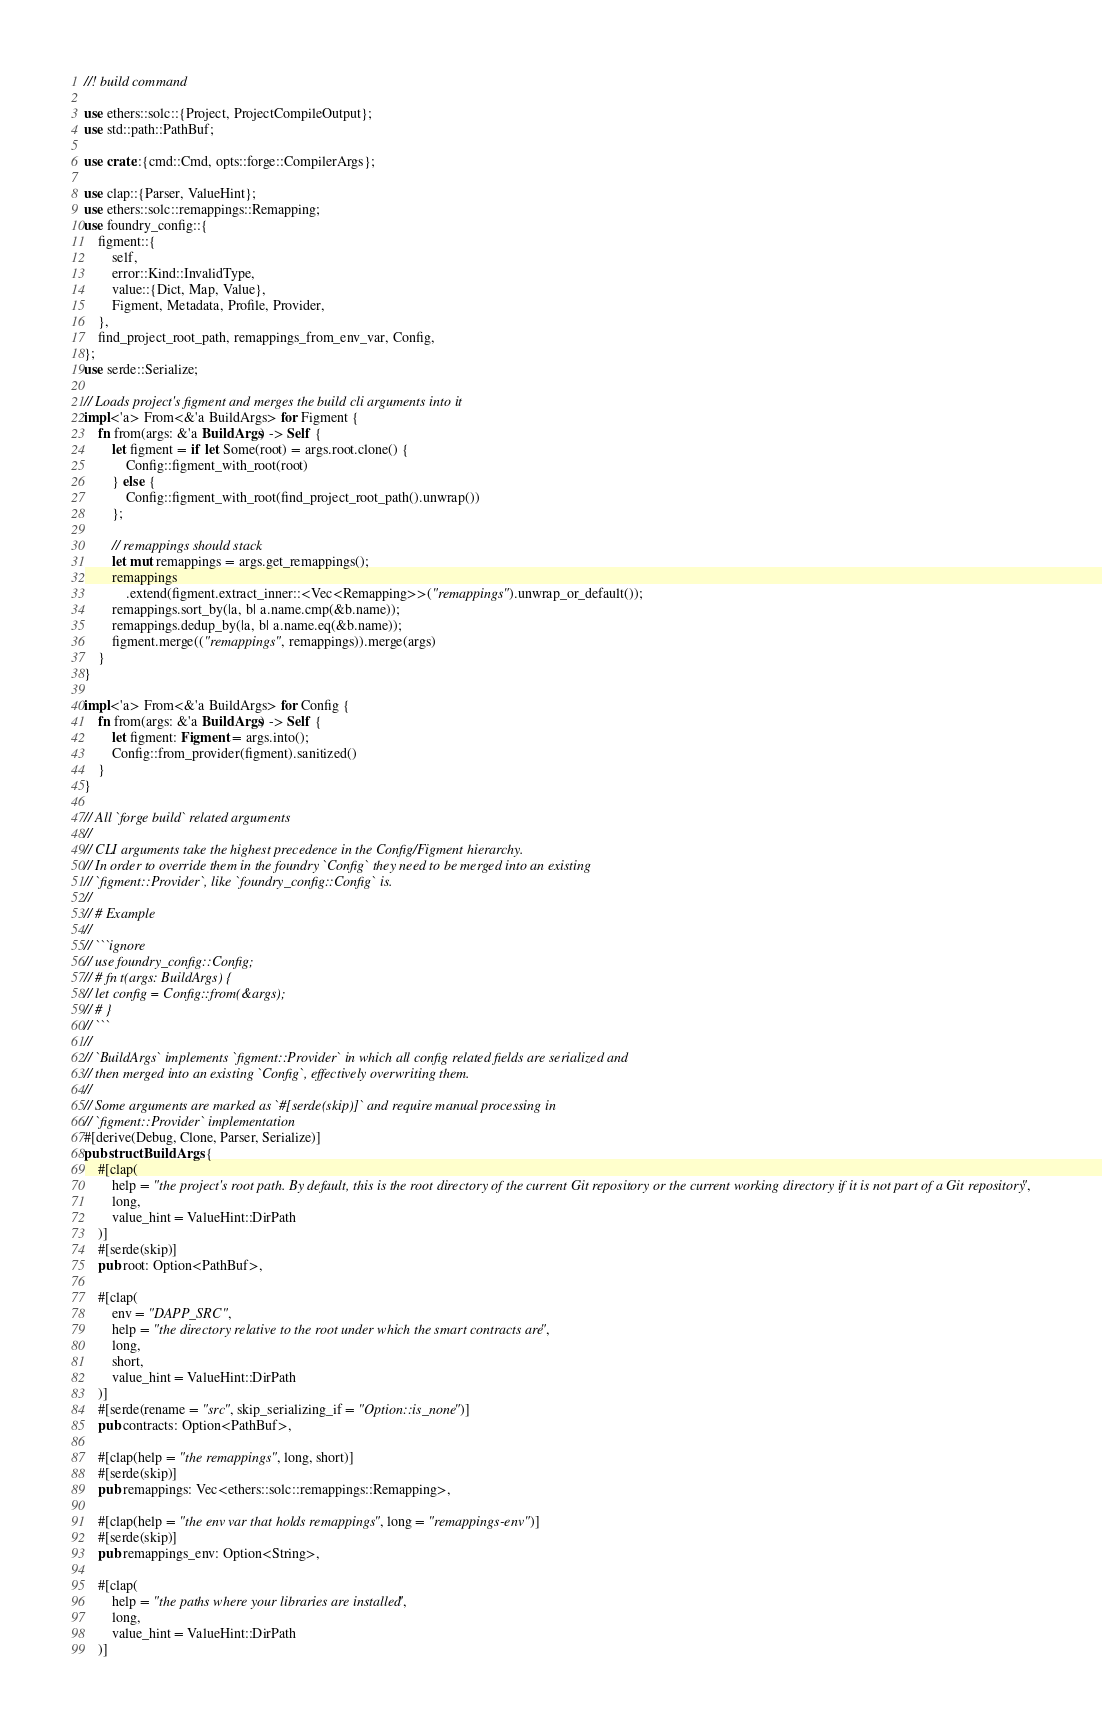<code> <loc_0><loc_0><loc_500><loc_500><_Rust_>//! build command

use ethers::solc::{Project, ProjectCompileOutput};
use std::path::PathBuf;

use crate::{cmd::Cmd, opts::forge::CompilerArgs};

use clap::{Parser, ValueHint};
use ethers::solc::remappings::Remapping;
use foundry_config::{
    figment::{
        self,
        error::Kind::InvalidType,
        value::{Dict, Map, Value},
        Figment, Metadata, Profile, Provider,
    },
    find_project_root_path, remappings_from_env_var, Config,
};
use serde::Serialize;

// Loads project's figment and merges the build cli arguments into it
impl<'a> From<&'a BuildArgs> for Figment {
    fn from(args: &'a BuildArgs) -> Self {
        let figment = if let Some(root) = args.root.clone() {
            Config::figment_with_root(root)
        } else {
            Config::figment_with_root(find_project_root_path().unwrap())
        };

        // remappings should stack
        let mut remappings = args.get_remappings();
        remappings
            .extend(figment.extract_inner::<Vec<Remapping>>("remappings").unwrap_or_default());
        remappings.sort_by(|a, b| a.name.cmp(&b.name));
        remappings.dedup_by(|a, b| a.name.eq(&b.name));
        figment.merge(("remappings", remappings)).merge(args)
    }
}

impl<'a> From<&'a BuildArgs> for Config {
    fn from(args: &'a BuildArgs) -> Self {
        let figment: Figment = args.into();
        Config::from_provider(figment).sanitized()
    }
}

// All `forge build` related arguments
//
// CLI arguments take the highest precedence in the Config/Figment hierarchy.
// In order to override them in the foundry `Config` they need to be merged into an existing
// `figment::Provider`, like `foundry_config::Config` is.
//
// # Example
//
// ```ignore
// use foundry_config::Config;
// # fn t(args: BuildArgs) {
// let config = Config::from(&args);
// # }
// ```
//
// `BuildArgs` implements `figment::Provider` in which all config related fields are serialized and
// then merged into an existing `Config`, effectively overwriting them.
//
// Some arguments are marked as `#[serde(skip)]` and require manual processing in
// `figment::Provider` implementation
#[derive(Debug, Clone, Parser, Serialize)]
pub struct BuildArgs {
    #[clap(
        help = "the project's root path. By default, this is the root directory of the current Git repository or the current working directory if it is not part of a Git repository",
        long,
        value_hint = ValueHint::DirPath
    )]
    #[serde(skip)]
    pub root: Option<PathBuf>,

    #[clap(
        env = "DAPP_SRC",
        help = "the directory relative to the root under which the smart contracts are",
        long,
        short,
        value_hint = ValueHint::DirPath
    )]
    #[serde(rename = "src", skip_serializing_if = "Option::is_none")]
    pub contracts: Option<PathBuf>,

    #[clap(help = "the remappings", long, short)]
    #[serde(skip)]
    pub remappings: Vec<ethers::solc::remappings::Remapping>,

    #[clap(help = "the env var that holds remappings", long = "remappings-env")]
    #[serde(skip)]
    pub remappings_env: Option<String>,

    #[clap(
        help = "the paths where your libraries are installed",
        long,
        value_hint = ValueHint::DirPath
    )]</code> 